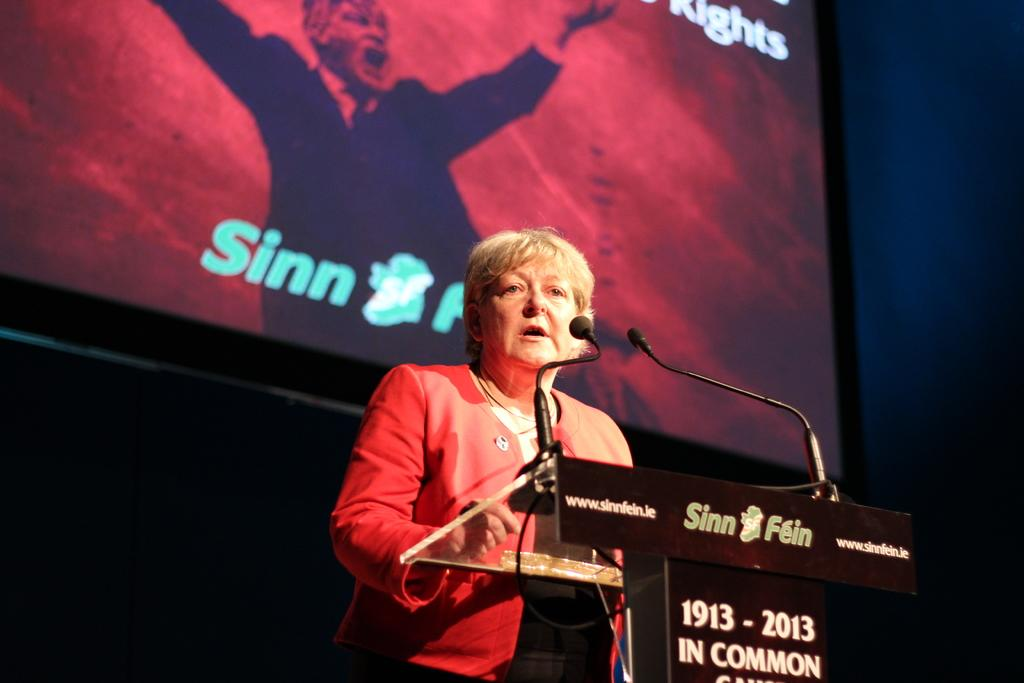<image>
Relay a brief, clear account of the picture shown. A woman standing in front of a podium reading 1913-2013. 